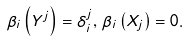<formula> <loc_0><loc_0><loc_500><loc_500>\beta _ { i } \left ( Y ^ { j } \right ) = \delta _ { i } ^ { j } , \, \beta _ { i } \left ( X _ { j } \right ) = 0 .</formula> 